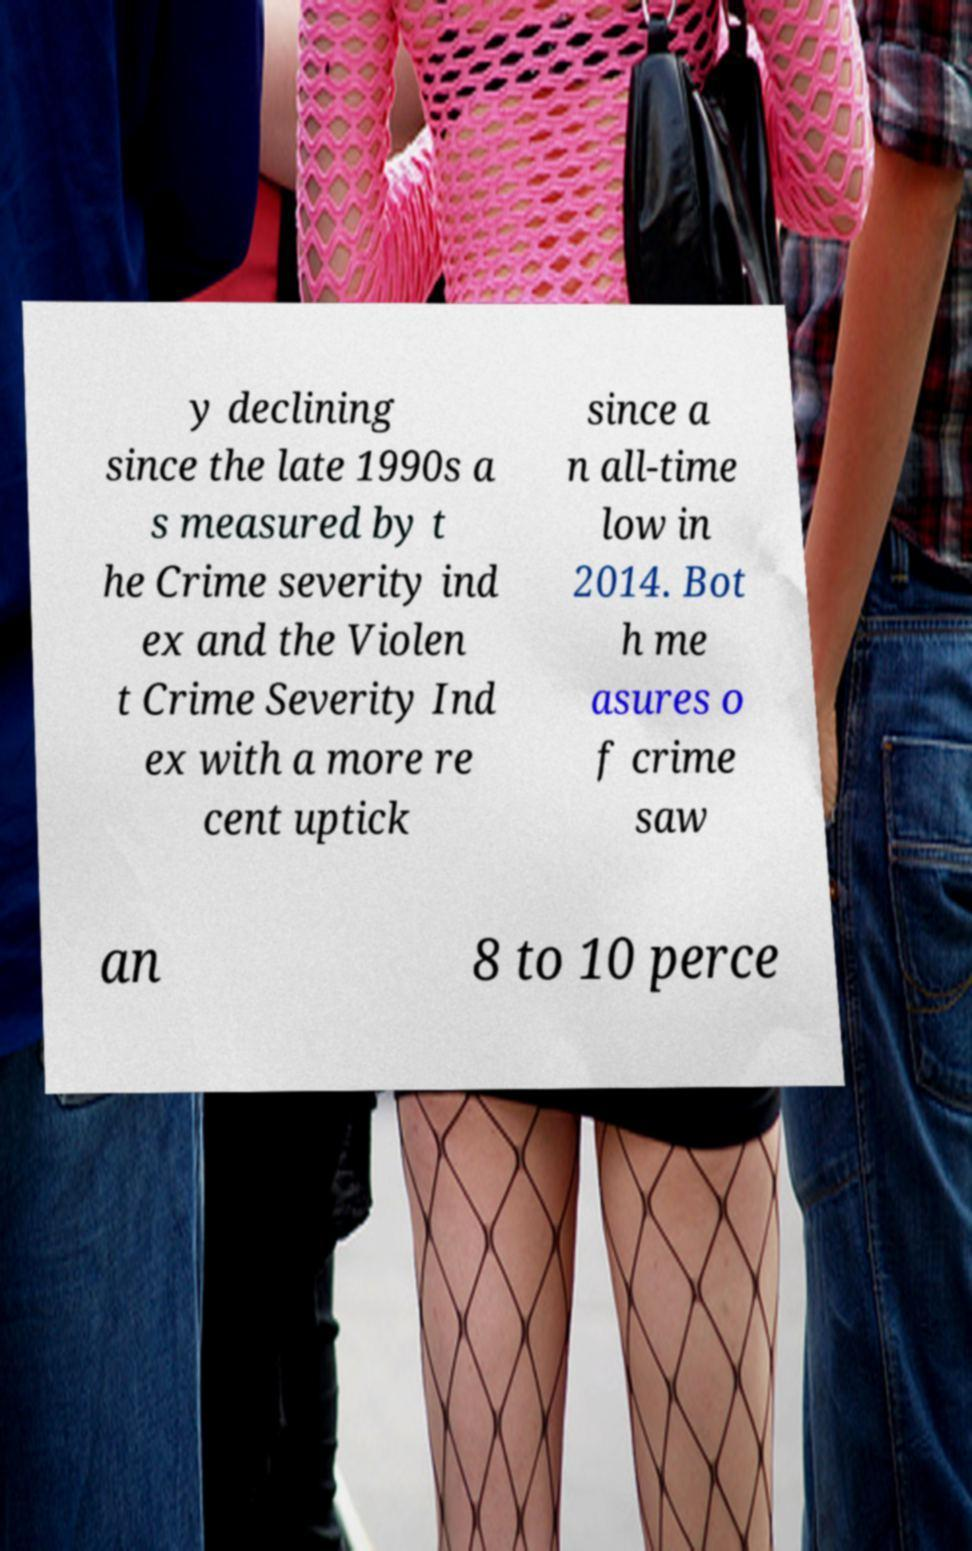Please identify and transcribe the text found in this image. y declining since the late 1990s a s measured by t he Crime severity ind ex and the Violen t Crime Severity Ind ex with a more re cent uptick since a n all-time low in 2014. Bot h me asures o f crime saw an 8 to 10 perce 